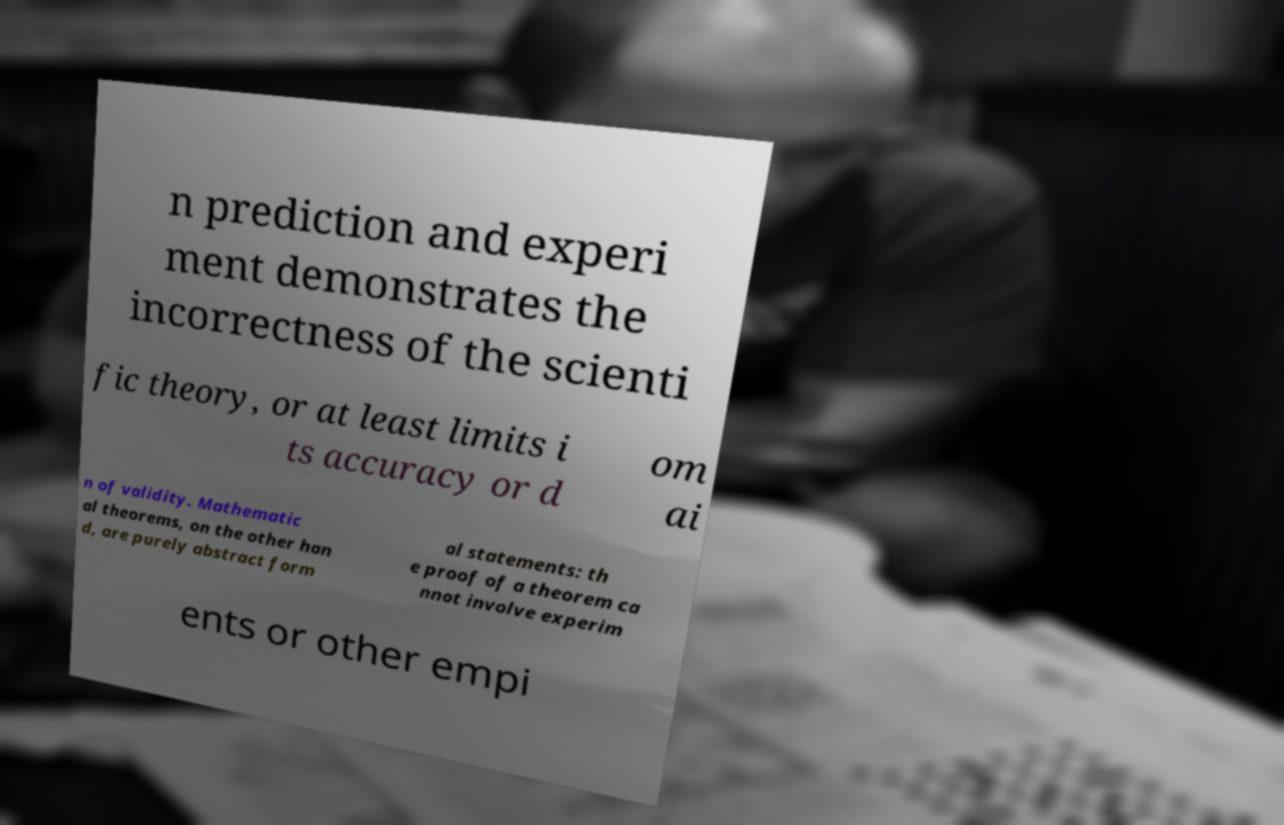For documentation purposes, I need the text within this image transcribed. Could you provide that? n prediction and experi ment demonstrates the incorrectness of the scienti fic theory, or at least limits i ts accuracy or d om ai n of validity. Mathematic al theorems, on the other han d, are purely abstract form al statements: th e proof of a theorem ca nnot involve experim ents or other empi 